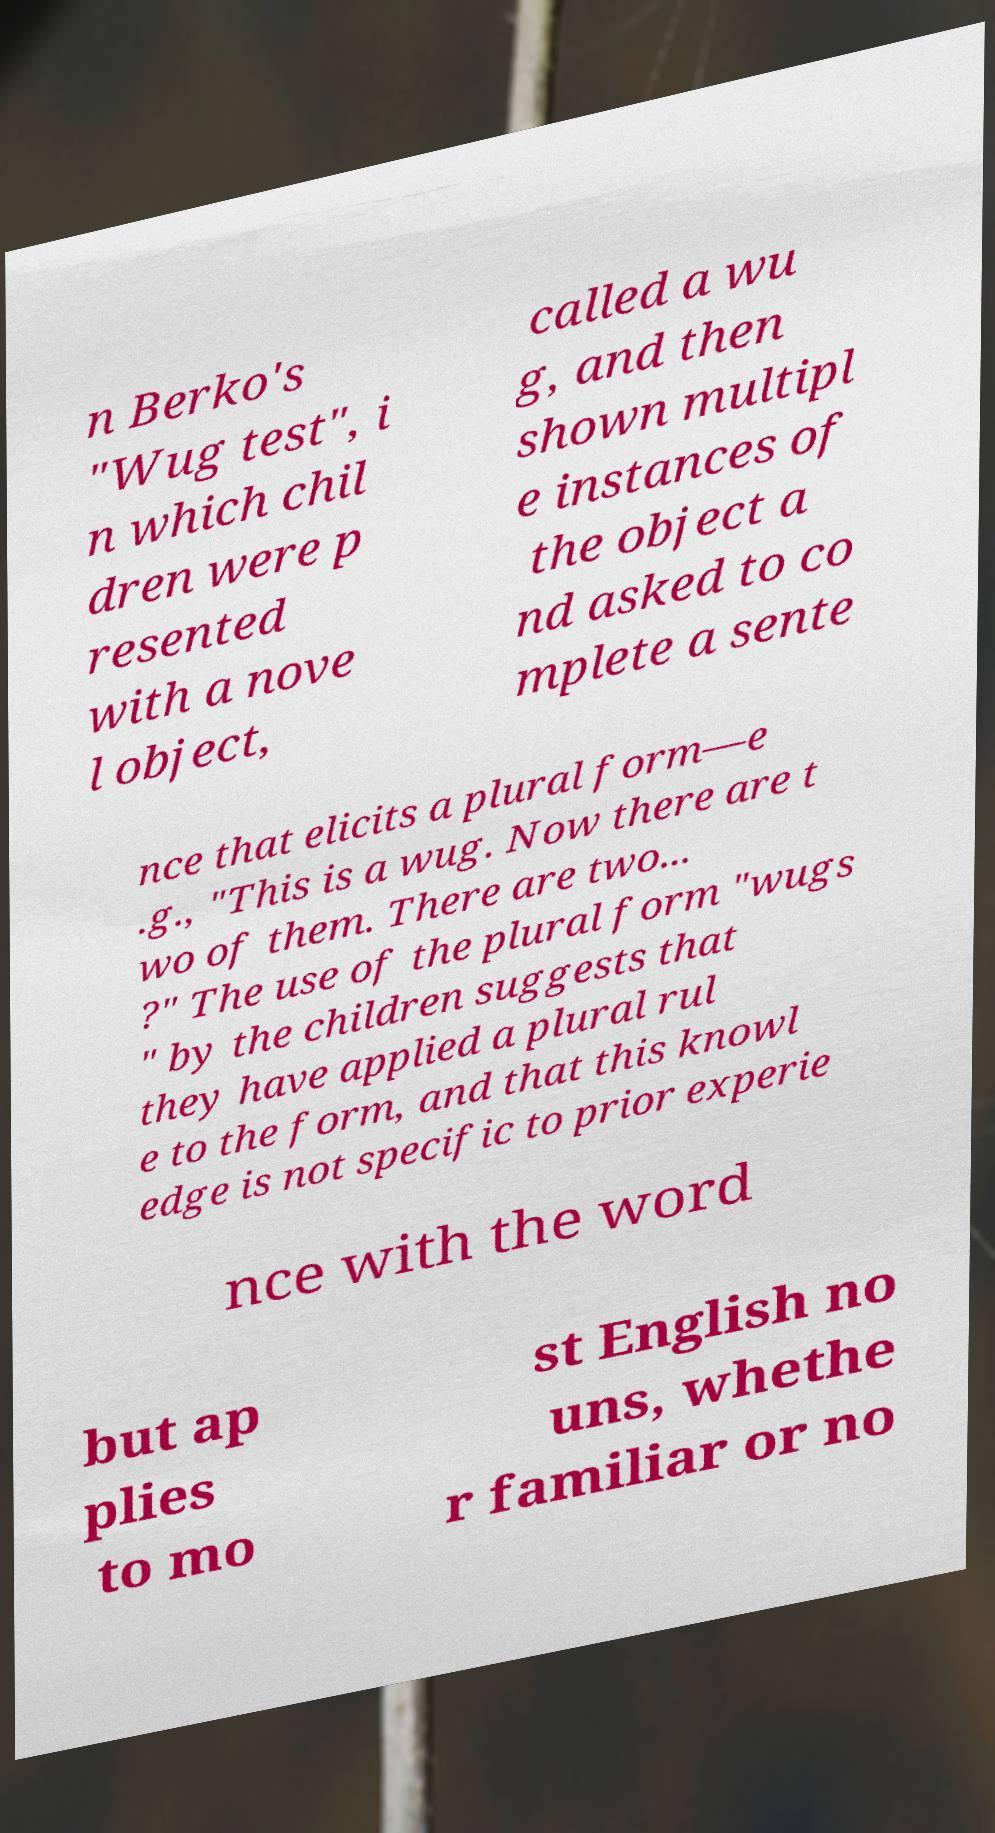What messages or text are displayed in this image? I need them in a readable, typed format. n Berko's "Wug test", i n which chil dren were p resented with a nove l object, called a wu g, and then shown multipl e instances of the object a nd asked to co mplete a sente nce that elicits a plural form—e .g., "This is a wug. Now there are t wo of them. There are two... ?" The use of the plural form "wugs " by the children suggests that they have applied a plural rul e to the form, and that this knowl edge is not specific to prior experie nce with the word but ap plies to mo st English no uns, whethe r familiar or no 